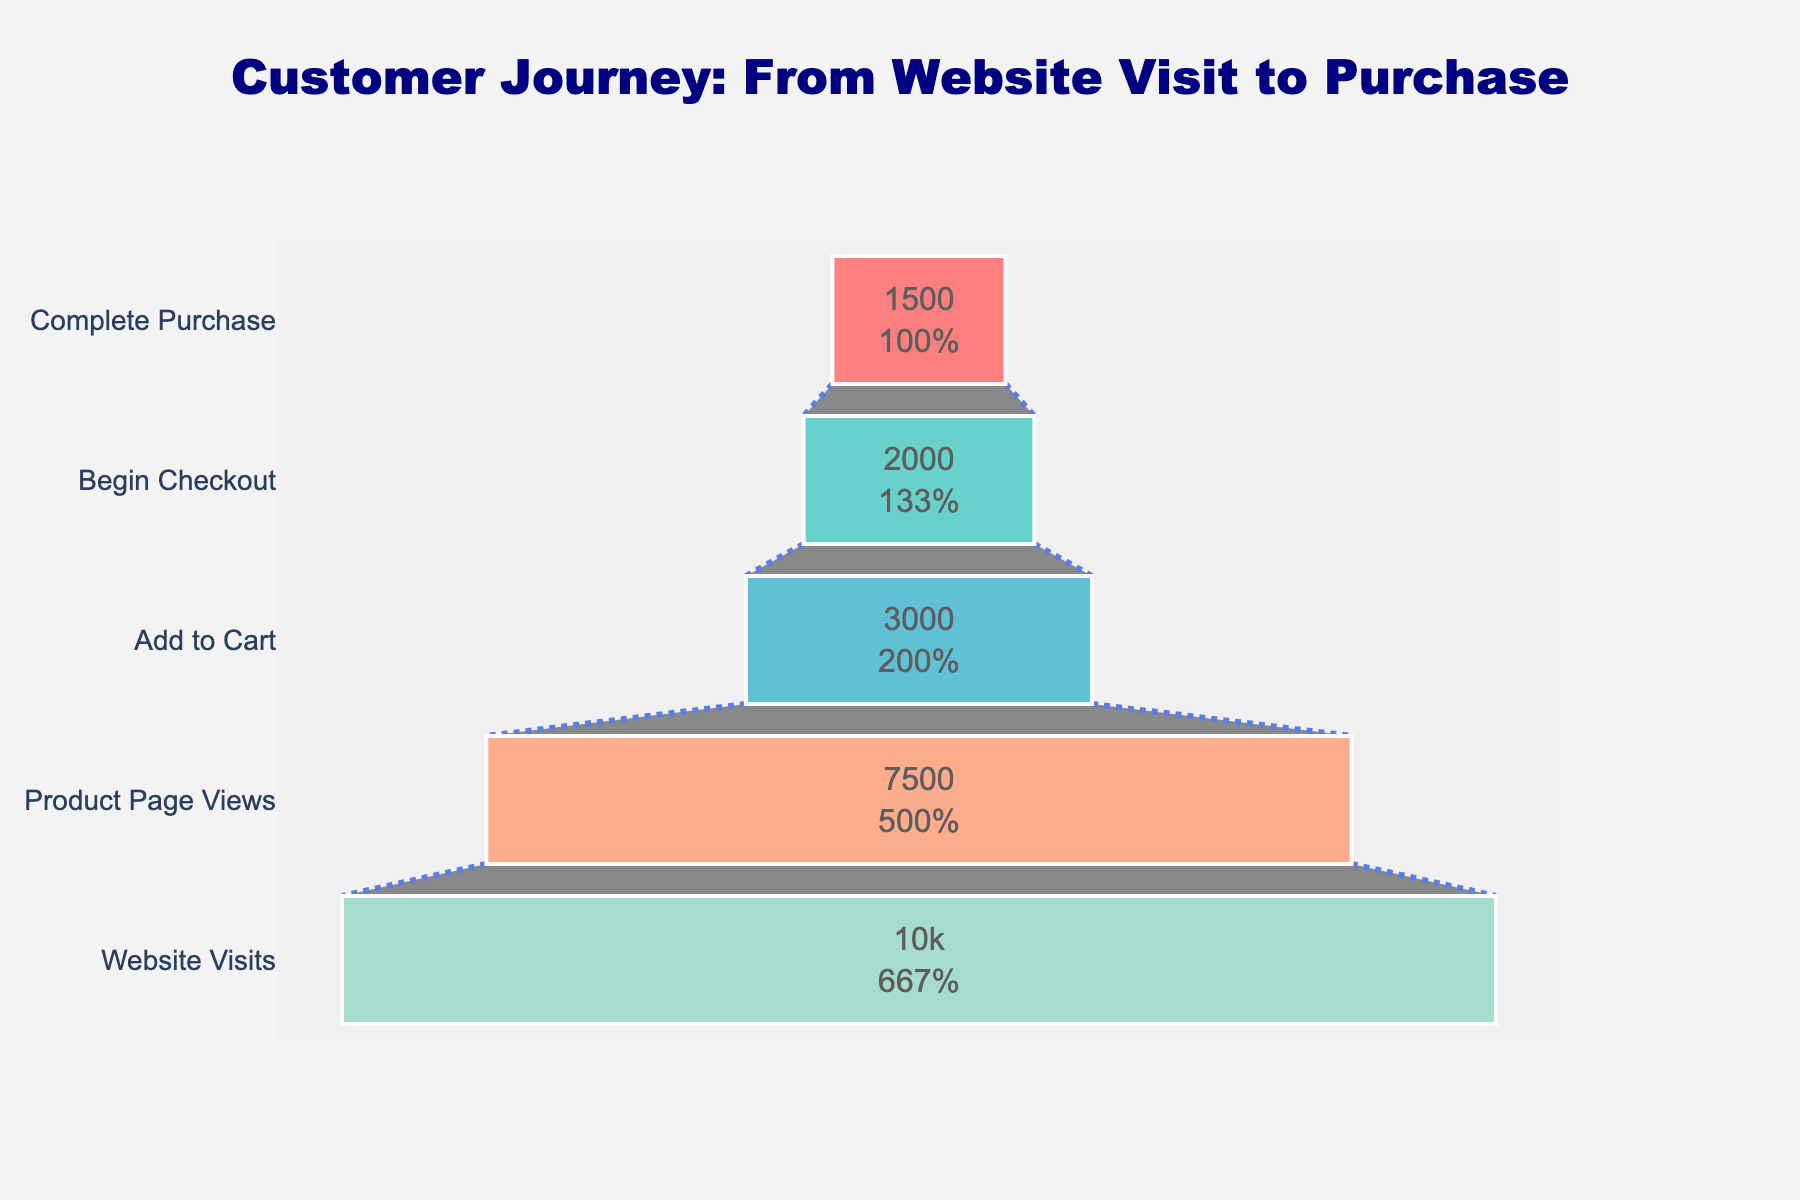what is the title of the figure? The title is at the top of the figure, clearly displayed to explain what the data represents. The wording in the title provides context about the stages depicted in the funnel.
Answer: Customer Journey: From Website Visit to Purchase how many stages are shown in the funnel chart? Count the number of distinct labeled sections in the funnel chart to determine the number of stages.
Answer: 5 what is the total number of visitors that completed the purchase? Look for the number at the bottom stage labeled "Complete Purchase".
Answer: 1,500 what percentage of visitors added products to their cart? Identify the "Add to Cart" stage and its corresponding percentage. This information is usually shown within the stage in the funnel chart.
Answer: 30% which stage has the highest drop-off of visitors? Calculate the difference in visitor numbers between each consecutive stage to find the maximum.
Answer: Product Page Views to Add to Cart compare the number of visitors who began checkout to those who completed the purchase. which is greater? Look at the numbers for "Begin Checkout" and "Complete Purchase". Compare these figures to see which one is larger.
Answer: Begin Checkout how many visitors left after viewing the product page without adding to cart? Subtract the number of visitors in the "Add to Cart" stage from the number in the "Product Page Views" stage.
Answer: 4,500 what is the percentage of visitors who began checkout out of those who added to cart? Calculate the percentage by dividing the number in the "Begin Checkout" stage by the number in the "Add to Cart" stage and multiplying by 100.
Answer: 66.67% if the website had 20000 visitors instead of 10000 with the same conversion rates, how many would likely complete the purchase? Double the number for each stage while maintaining the same conversion percentage. For "Complete Purchase," it would be 1500 * 2.
Answer: 3,000 what is the color scheme used for different stages in the funnel? Identify the distinct colors used for each funnel stage, typically shown in different shades to enhance visual distinction.
Answer: Red, teal, sky blue, salmon, mint green 